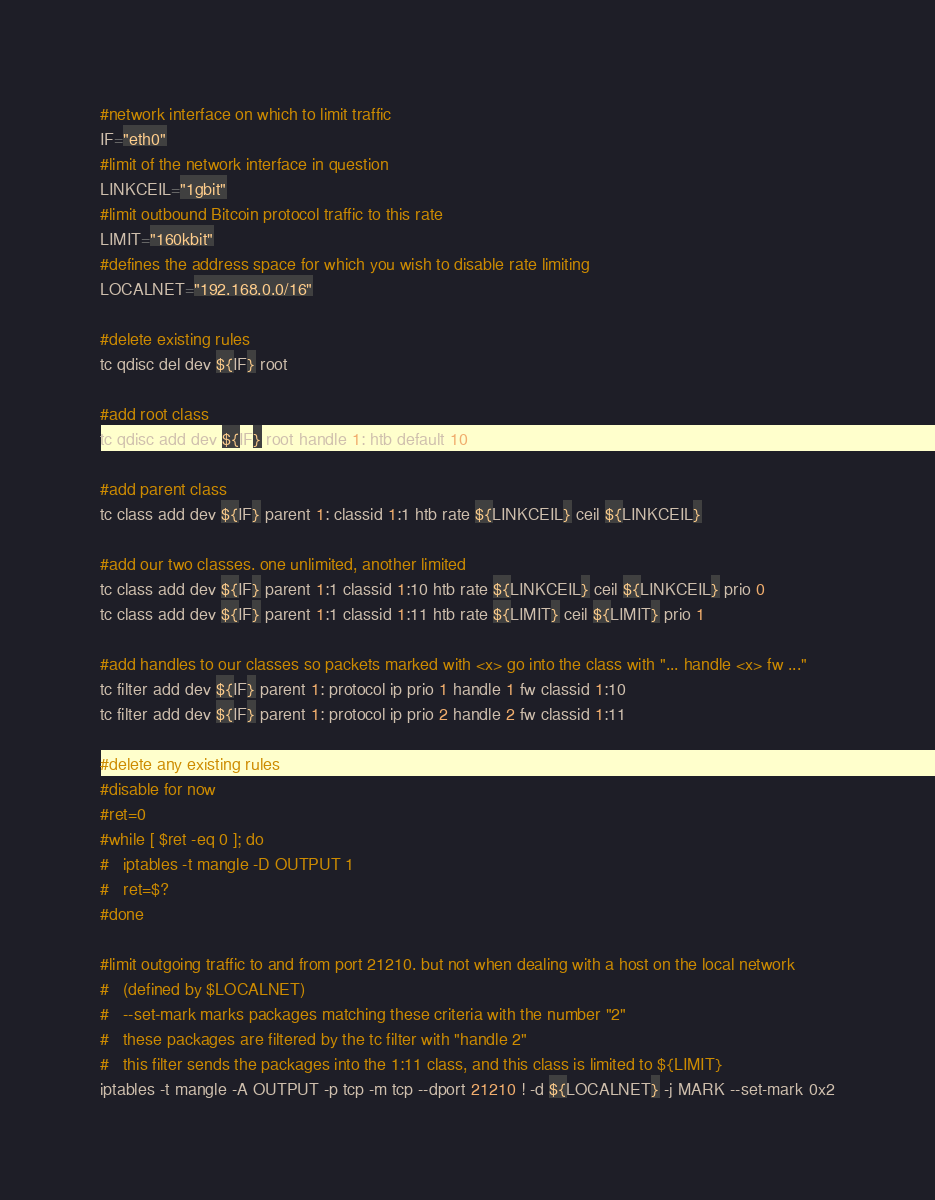<code> <loc_0><loc_0><loc_500><loc_500><_Bash_>#network interface on which to limit traffic
IF="eth0"
#limit of the network interface in question
LINKCEIL="1gbit"
#limit outbound Bitcoin protocol traffic to this rate
LIMIT="160kbit"
#defines the address space for which you wish to disable rate limiting
LOCALNET="192.168.0.0/16"

#delete existing rules
tc qdisc del dev ${IF} root

#add root class
tc qdisc add dev ${IF} root handle 1: htb default 10

#add parent class
tc class add dev ${IF} parent 1: classid 1:1 htb rate ${LINKCEIL} ceil ${LINKCEIL}

#add our two classes. one unlimited, another limited
tc class add dev ${IF} parent 1:1 classid 1:10 htb rate ${LINKCEIL} ceil ${LINKCEIL} prio 0
tc class add dev ${IF} parent 1:1 classid 1:11 htb rate ${LIMIT} ceil ${LIMIT} prio 1

#add handles to our classes so packets marked with <x> go into the class with "... handle <x> fw ..."
tc filter add dev ${IF} parent 1: protocol ip prio 1 handle 1 fw classid 1:10
tc filter add dev ${IF} parent 1: protocol ip prio 2 handle 2 fw classid 1:11

#delete any existing rules
#disable for now
#ret=0
#while [ $ret -eq 0 ]; do
#	iptables -t mangle -D OUTPUT 1
#	ret=$?
#done

#limit outgoing traffic to and from port 21210. but not when dealing with a host on the local network
#	(defined by $LOCALNET)
#	--set-mark marks packages matching these criteria with the number "2"
#	these packages are filtered by the tc filter with "handle 2"
#	this filter sends the packages into the 1:11 class, and this class is limited to ${LIMIT}
iptables -t mangle -A OUTPUT -p tcp -m tcp --dport 21210 ! -d ${LOCALNET} -j MARK --set-mark 0x2</code> 